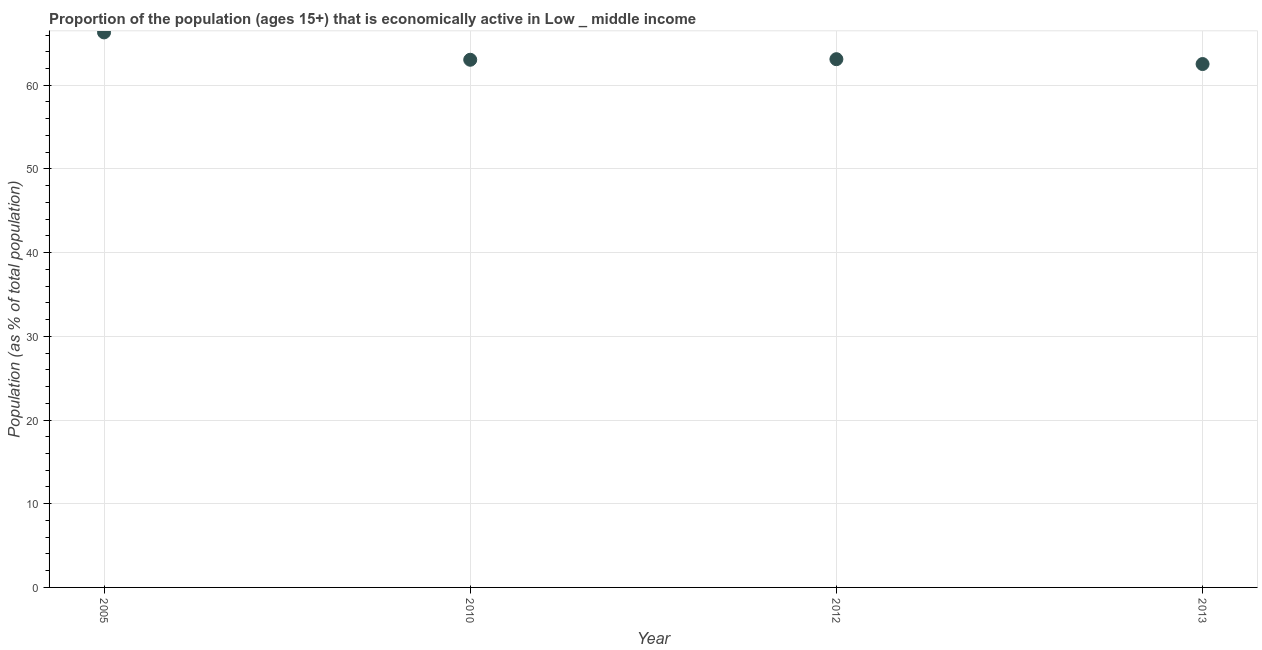What is the percentage of economically active population in 2012?
Provide a succinct answer. 63.12. Across all years, what is the maximum percentage of economically active population?
Your answer should be very brief. 66.31. Across all years, what is the minimum percentage of economically active population?
Your response must be concise. 62.53. In which year was the percentage of economically active population maximum?
Your response must be concise. 2005. What is the sum of the percentage of economically active population?
Ensure brevity in your answer.  255.01. What is the difference between the percentage of economically active population in 2012 and 2013?
Your answer should be very brief. 0.58. What is the average percentage of economically active population per year?
Offer a terse response. 63.75. What is the median percentage of economically active population?
Provide a short and direct response. 63.08. Do a majority of the years between 2013 and 2012 (inclusive) have percentage of economically active population greater than 10 %?
Provide a succinct answer. No. What is the ratio of the percentage of economically active population in 2005 to that in 2013?
Your answer should be compact. 1.06. Is the percentage of economically active population in 2005 less than that in 2010?
Your answer should be very brief. No. What is the difference between the highest and the second highest percentage of economically active population?
Offer a very short reply. 3.2. What is the difference between the highest and the lowest percentage of economically active population?
Make the answer very short. 3.78. Does the percentage of economically active population monotonically increase over the years?
Give a very brief answer. No. How many dotlines are there?
Make the answer very short. 1. Are the values on the major ticks of Y-axis written in scientific E-notation?
Provide a succinct answer. No. Does the graph contain any zero values?
Offer a very short reply. No. What is the title of the graph?
Provide a succinct answer. Proportion of the population (ages 15+) that is economically active in Low _ middle income. What is the label or title of the X-axis?
Your response must be concise. Year. What is the label or title of the Y-axis?
Your answer should be compact. Population (as % of total population). What is the Population (as % of total population) in 2005?
Keep it short and to the point. 66.31. What is the Population (as % of total population) in 2010?
Your answer should be compact. 63.05. What is the Population (as % of total population) in 2012?
Give a very brief answer. 63.12. What is the Population (as % of total population) in 2013?
Your response must be concise. 62.53. What is the difference between the Population (as % of total population) in 2005 and 2010?
Offer a very short reply. 3.27. What is the difference between the Population (as % of total population) in 2005 and 2012?
Provide a succinct answer. 3.2. What is the difference between the Population (as % of total population) in 2005 and 2013?
Give a very brief answer. 3.78. What is the difference between the Population (as % of total population) in 2010 and 2012?
Make the answer very short. -0.07. What is the difference between the Population (as % of total population) in 2010 and 2013?
Your response must be concise. 0.51. What is the difference between the Population (as % of total population) in 2012 and 2013?
Make the answer very short. 0.58. What is the ratio of the Population (as % of total population) in 2005 to that in 2010?
Ensure brevity in your answer.  1.05. What is the ratio of the Population (as % of total population) in 2005 to that in 2012?
Your answer should be compact. 1.05. What is the ratio of the Population (as % of total population) in 2005 to that in 2013?
Ensure brevity in your answer.  1.06. What is the ratio of the Population (as % of total population) in 2012 to that in 2013?
Make the answer very short. 1.01. 